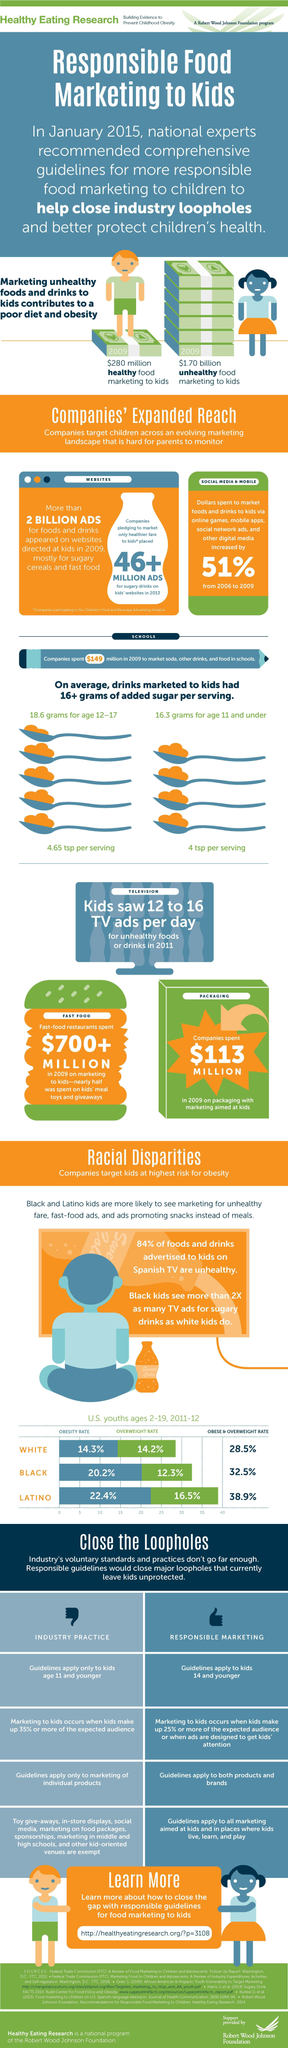What is the difference between Obese and Overweight rates in Latino and black?
Answer the question with a short phrase. 6.4% What percentage of foods and drinks advertised to kids on Spanish tv are healthy? 16% What is the difference between Obese and Overweight rate in black and white? 4% 